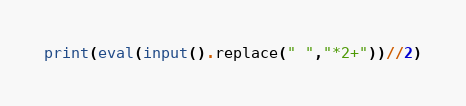Convert code to text. <code><loc_0><loc_0><loc_500><loc_500><_Python_>print(eval(input().replace(" ","*2+"))//2)</code> 